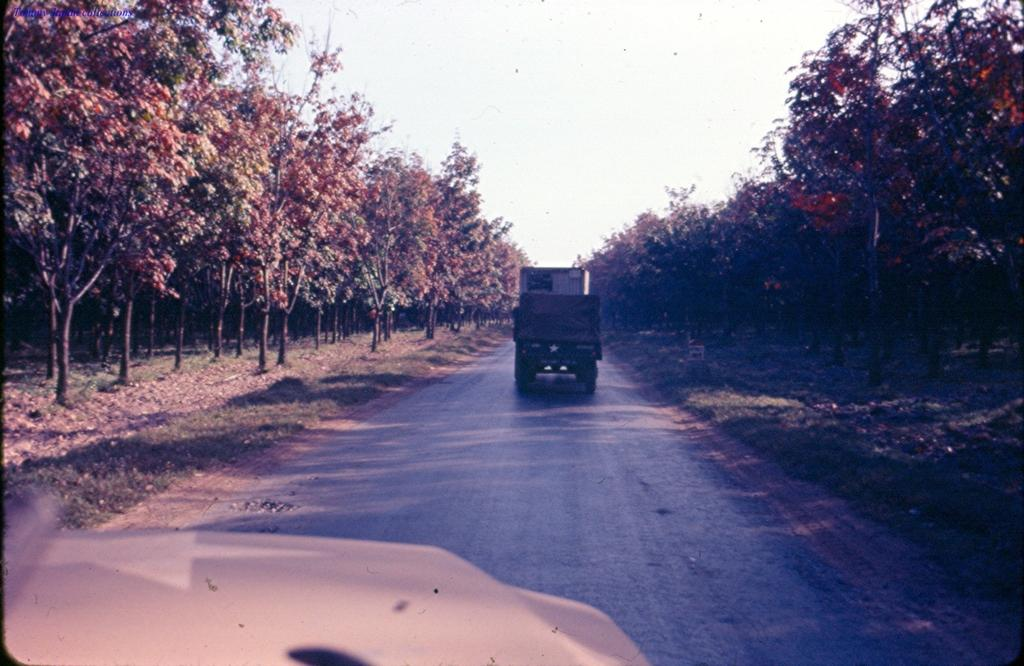What can be seen on the road in the image? There are vehicles on the road in the image. What type of vegetation is visible in the image? There is grass visible in the image, as well as a group of trees. What is visible in the background of the image? The sky is visible in the image and appears cloudy. Where is the playground located in the image? There is no playground present in the image. What type of land can be seen in the image? The image does not specifically show a type of land; it features a road, grass, trees, and a cloudy sky. 